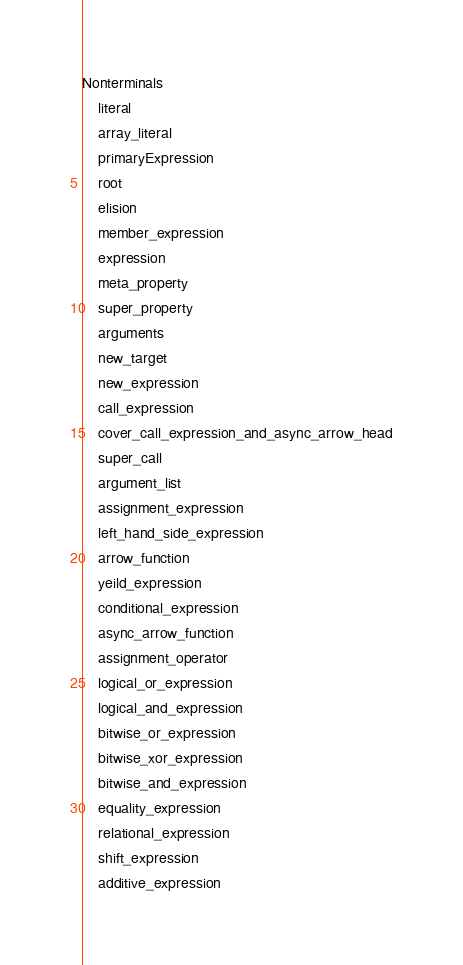Convert code to text. <code><loc_0><loc_0><loc_500><loc_500><_Erlang_>Nonterminals
    literal
    array_literal
    primaryExpression
    root
    elision
    member_expression
    expression
    meta_property
    super_property
    arguments
    new_target
    new_expression
    call_expression
    cover_call_expression_and_async_arrow_head
    super_call
    argument_list
    assignment_expression
    left_hand_side_expression
    arrow_function
    yeild_expression
    conditional_expression
    async_arrow_function
    assignment_operator
    logical_or_expression
    logical_and_expression
    bitwise_or_expression
    bitwise_xor_expression
    bitwise_and_expression
    equality_expression
    relational_expression
    shift_expression
    additive_expression</code> 